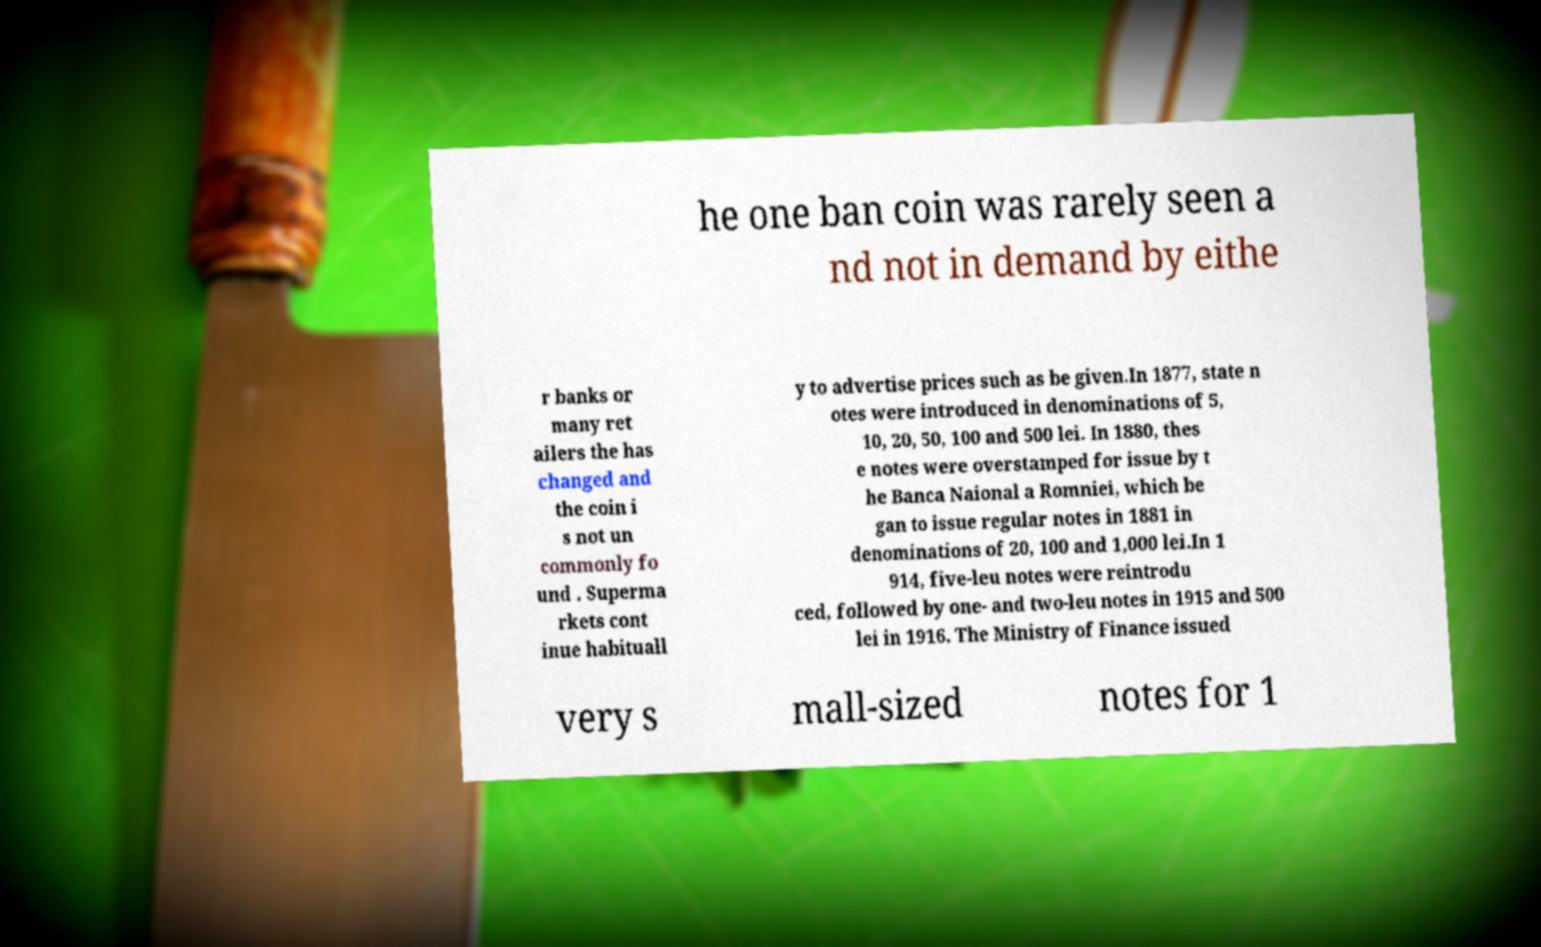Could you extract and type out the text from this image? he one ban coin was rarely seen a nd not in demand by eithe r banks or many ret ailers the has changed and the coin i s not un commonly fo und . Superma rkets cont inue habituall y to advertise prices such as be given.In 1877, state n otes were introduced in denominations of 5, 10, 20, 50, 100 and 500 lei. In 1880, thes e notes were overstamped for issue by t he Banca Naional a Romniei, which be gan to issue regular notes in 1881 in denominations of 20, 100 and 1,000 lei.In 1 914, five-leu notes were reintrodu ced, followed by one- and two-leu notes in 1915 and 500 lei in 1916. The Ministry of Finance issued very s mall-sized notes for 1 